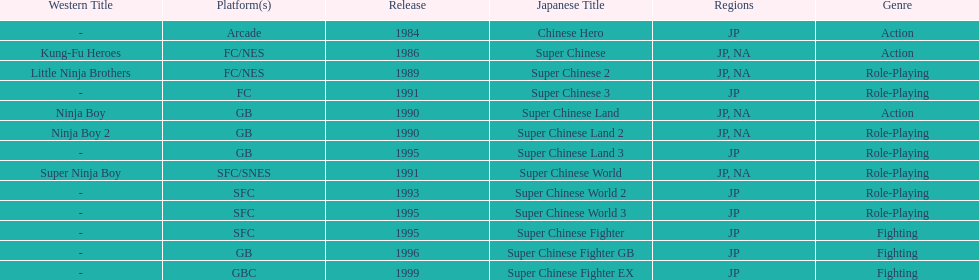How many action games were released in north america? 2. 